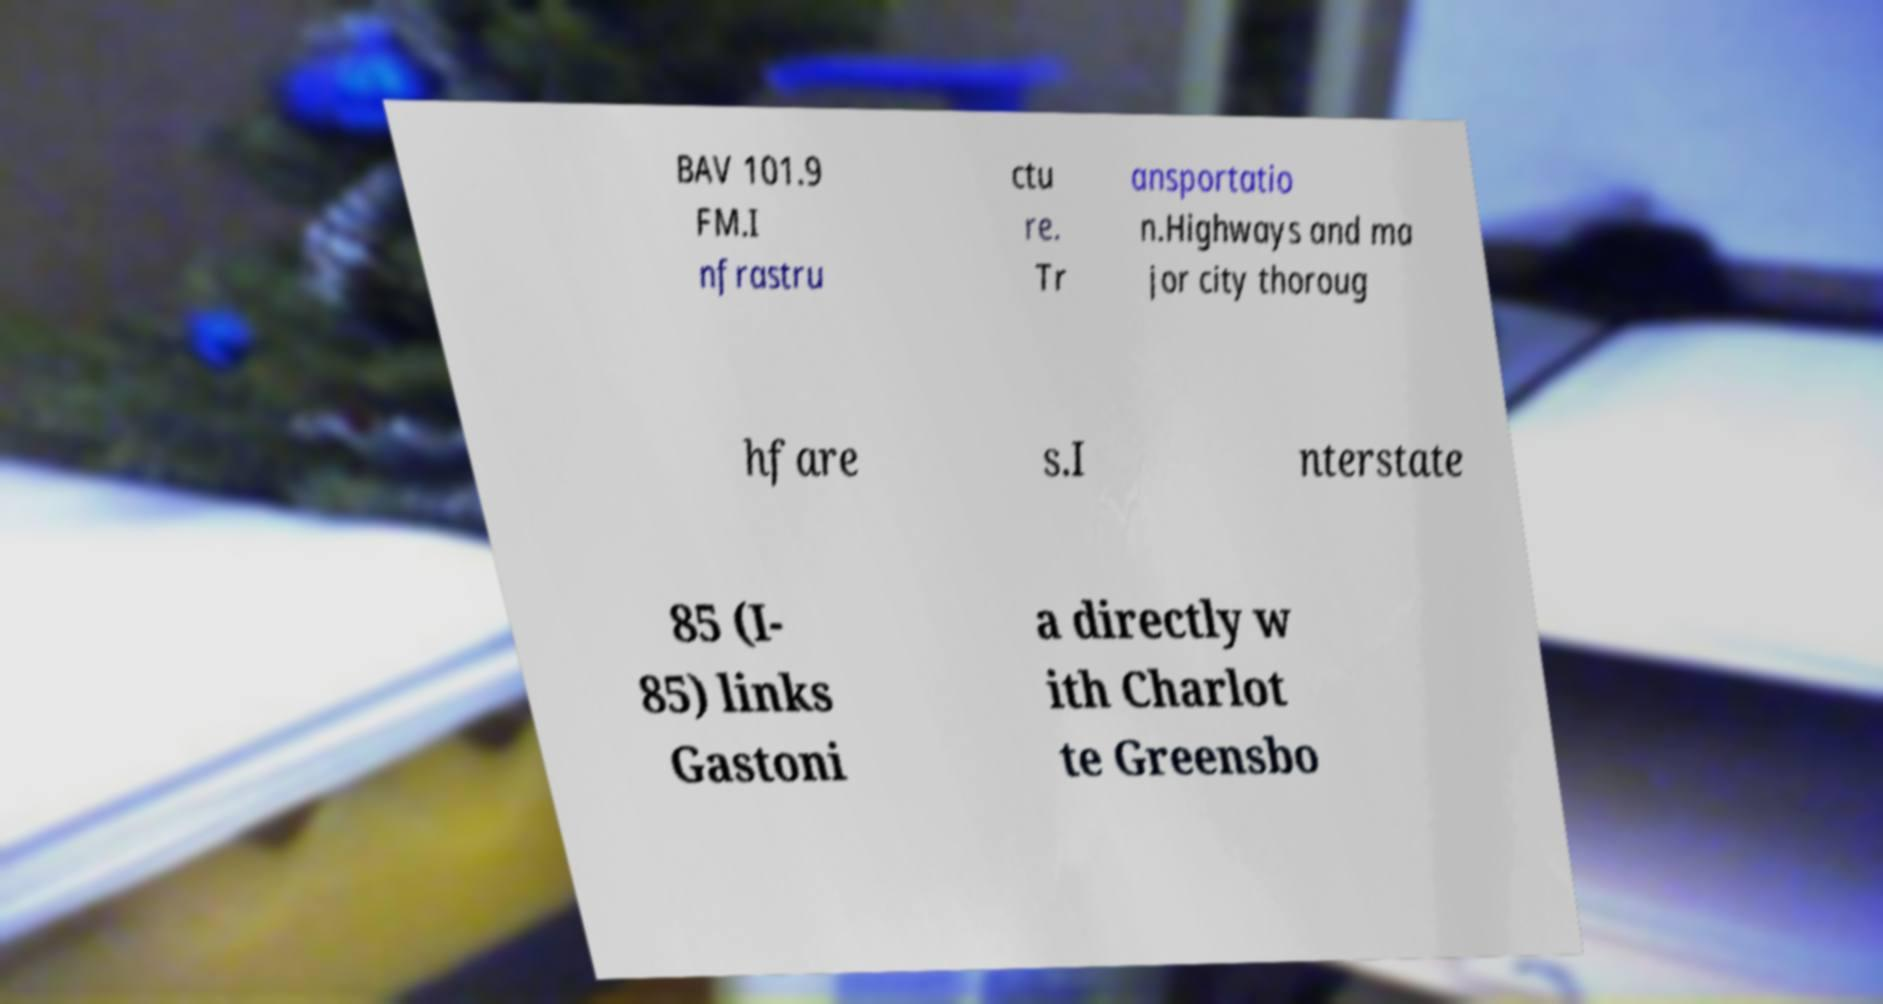Please read and relay the text visible in this image. What does it say? BAV 101.9 FM.I nfrastru ctu re. Tr ansportatio n.Highways and ma jor city thoroug hfare s.I nterstate 85 (I- 85) links Gastoni a directly w ith Charlot te Greensbo 